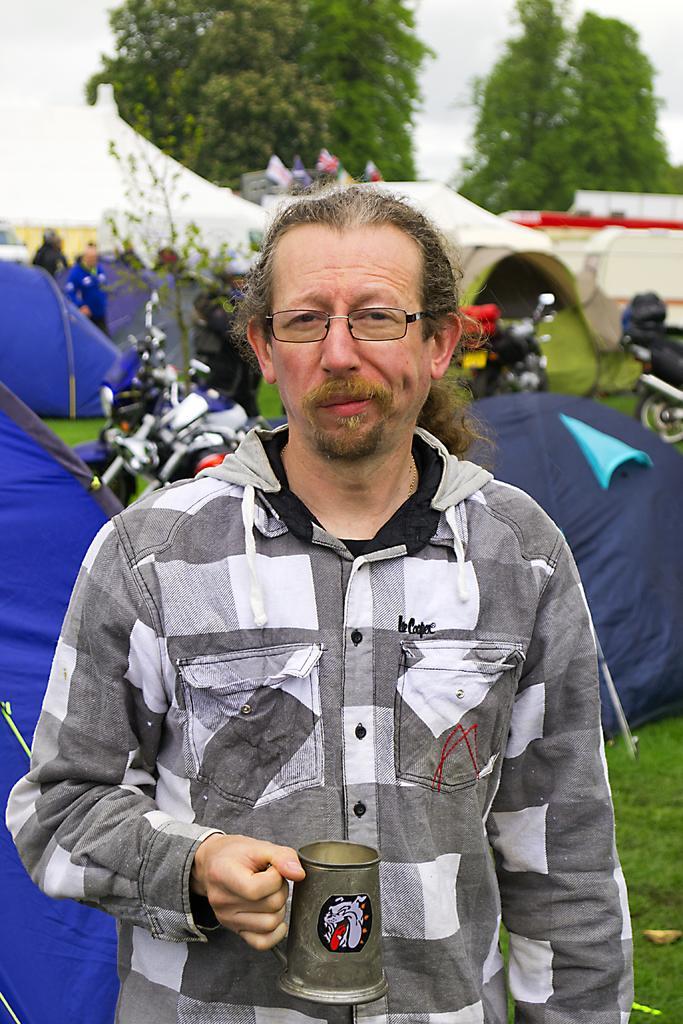Describe this image in one or two sentences. In this image I can see a person standing and holding the cup. To the back of him there are tents and the motorbikes. In the background there are trees and the sky. 